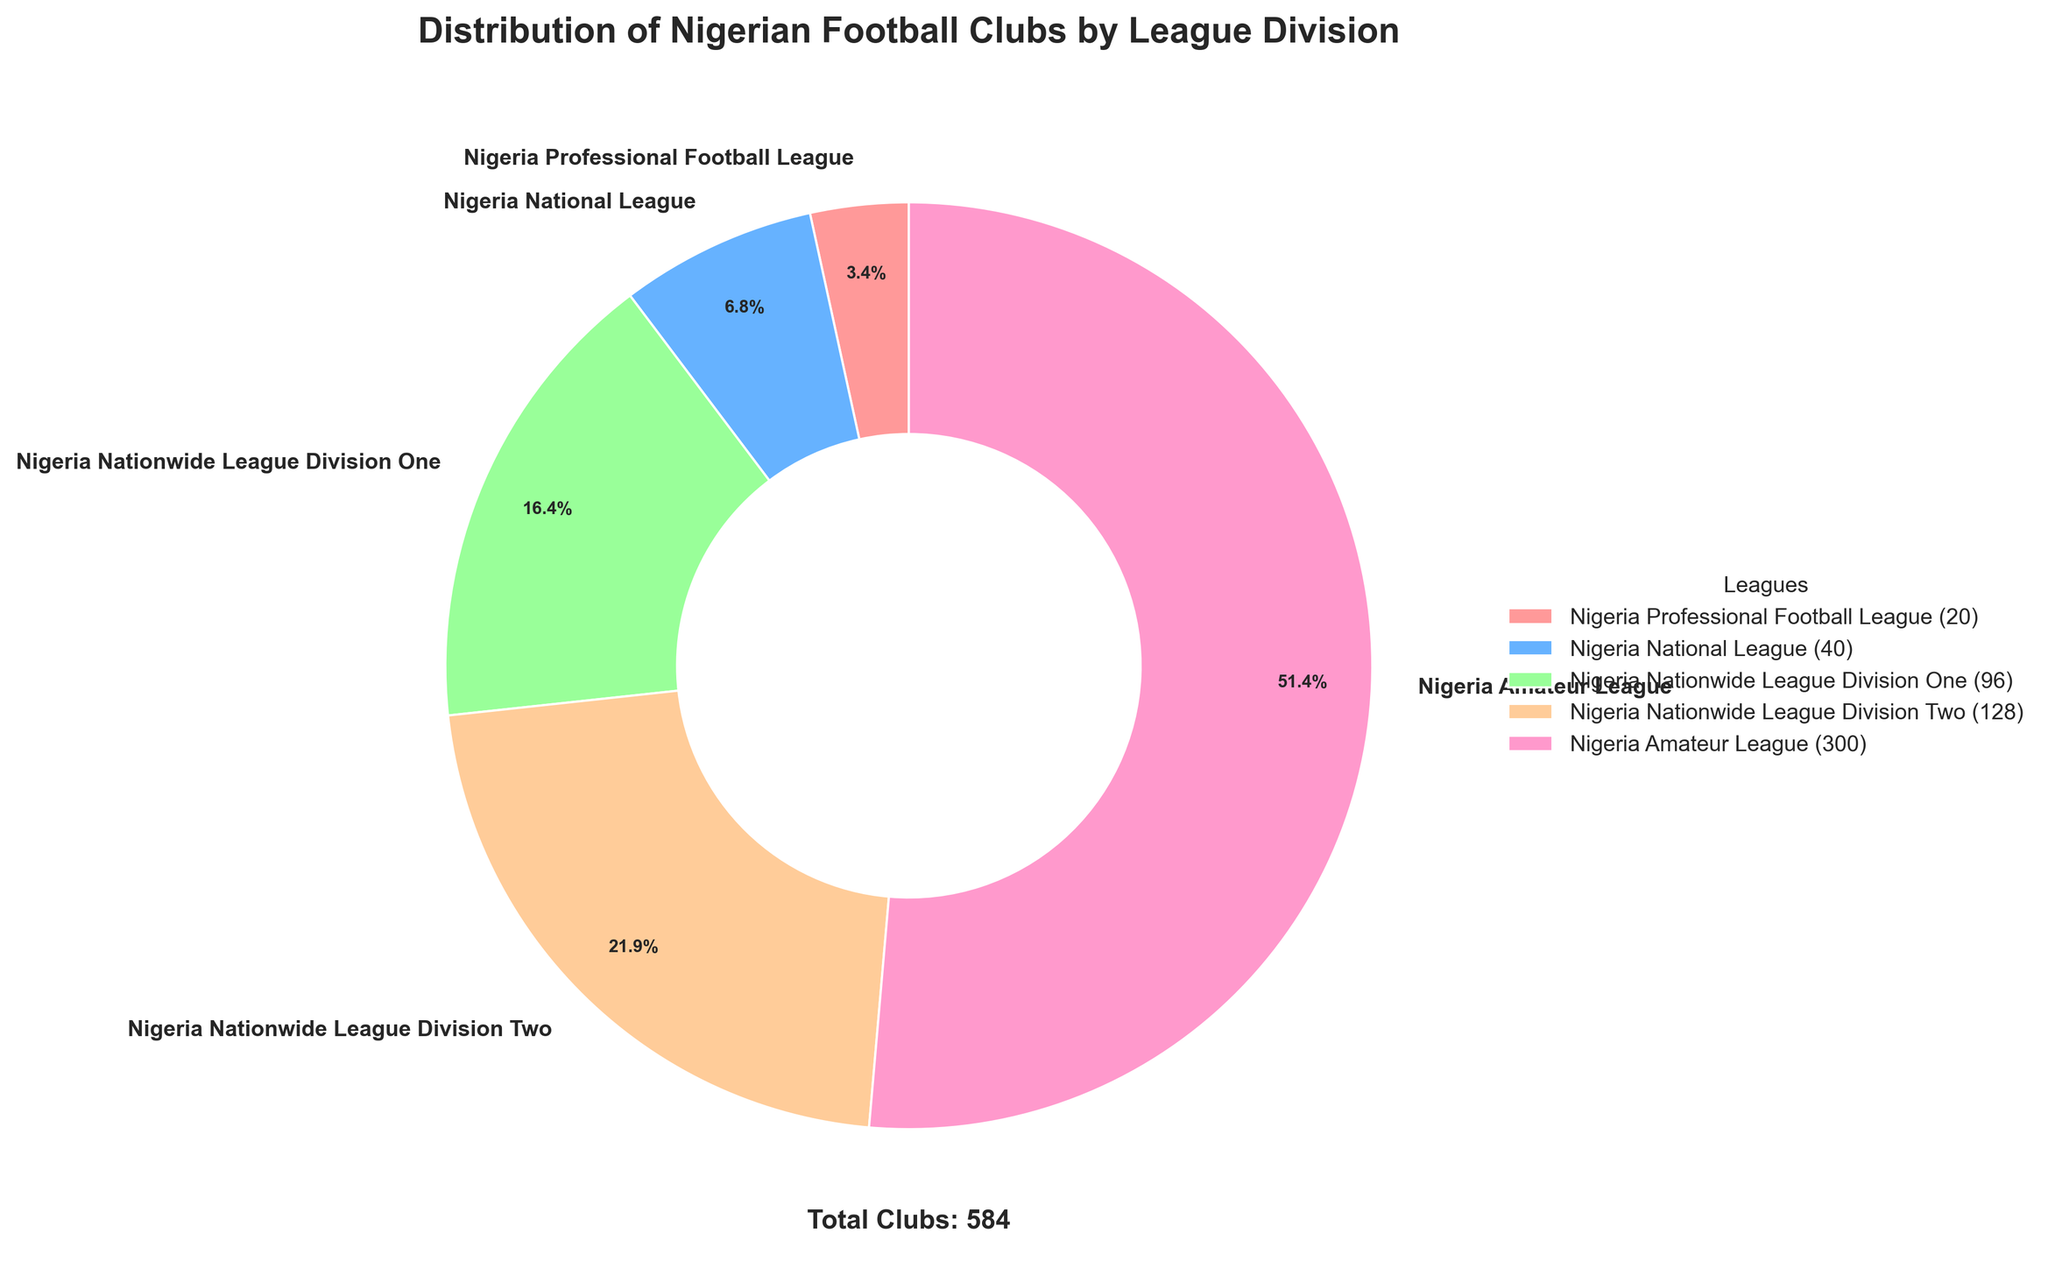What percentage of Nigerian football clubs are in the Nigeria National League? In the pie chart, look at the slice labeled "Nigeria National League." The autopct value on the chart shows percentages directly.
Answer: 8.6% Which league division has the largest number of clubs? In the pie chart, identify the largest slice. The slice with the largest area represents the division with the most clubs.
Answer: Nigeria Amateur League How many clubs are there in total across all league divisions? The pie chart’s subtitle states the total number of clubs, or sum the number of clubs in each division: 20 + 40 + 96 + 128 + 300.
Answer: 584 Compare the Nigeria Professional Football League and Nigeria Nationwide League Division Two: which has more clubs and by how many? Look at the values of the two slices. Nigeria Professional Football League has 20 clubs and Nigeria Nationwide League Division Two has 128. The difference is 128 - 20.
Answer: 108 What percentage of Nigerian football clubs are in the Nigeria Nationwide League Division One and Nigeria Nationwide League Division Two combined? Look at the percentages for both divisions: 16.4% for Nationwide League Division One, and 21.9% for Nationwide League Division Two. Add these percentages: 16.4% + 21.9%.
Answer: 38.3% Which league division contributes the least to the total number of football clubs? Find the smallest slice on the pie chart. The smallest slice represents the Nigeria Professional Football League.
Answer: Nigeria Professional Football League If the Nigeria Amateur League represents 51.4% of the total clubs, how many clubs are in the Nigeria Amateur League? Use the percentage provided and the total number of clubs (584). Calculate 51.4% of 584: (51.4/100) * 584.
Answer: 300 Is there any division with exactly twice the number of clubs compared to another division? Compare each pair of divisions’ number of clubs. Nigeria Nationwide League Division Two (128 clubs) is twice the number of clubs in the Nigeria National League (40 clubs).
Answer: Yes, Nigeria Nationwide League Division Two and Nigeria National League How does the percentage of clubs in the Nigeria Professional Football League compare to the percentage in the Nigeria National League? Look at the pie chart slices for both divisions. The Nigeria Professional Football League has 3.4%, while the Nigeria National League has 6.8%.
Answer: The Nigeria National League has a higher percentage What is the average number of clubs per division if divided equally among the five divisions? Divide the total number of clubs (584) by the number of divisions (5). The calculation is 584 / 5.
Answer: 116.8 